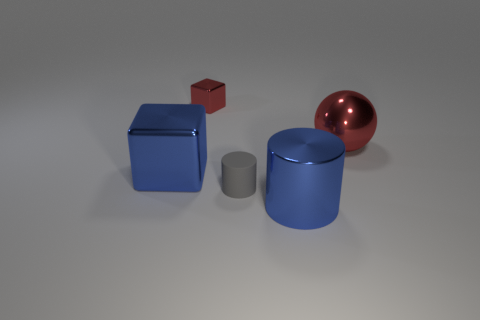Is there any other thing that has the same color as the small metallic object?
Provide a succinct answer. Yes. There is a metal object that is both to the left of the gray matte thing and in front of the small red metallic block; what shape is it?
Your answer should be very brief. Cube. Is there a large thing that is in front of the red metallic object that is right of the metal thing that is behind the red metallic ball?
Offer a terse response. Yes. What number of objects are shiny objects that are to the right of the large blue metallic block or metal things behind the big metal cube?
Your response must be concise. 3. Is the large blue thing that is in front of the gray cylinder made of the same material as the tiny red thing?
Ensure brevity in your answer.  Yes. There is a thing that is both behind the blue metallic cylinder and in front of the large blue metallic cube; what material is it?
Offer a terse response. Rubber. There is a block that is behind the large shiny object behind the blue block; what is its color?
Give a very brief answer. Red. There is a small thing on the right side of the tiny object left of the cylinder behind the large blue metal cylinder; what is its color?
Provide a succinct answer. Gray. How many things are large blue cylinders or tiny metallic blocks?
Make the answer very short. 2. How many other gray things are the same shape as the gray matte object?
Provide a succinct answer. 0. 